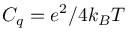<formula> <loc_0><loc_0><loc_500><loc_500>C _ { q } = e ^ { 2 } / 4 k _ { B } T</formula> 